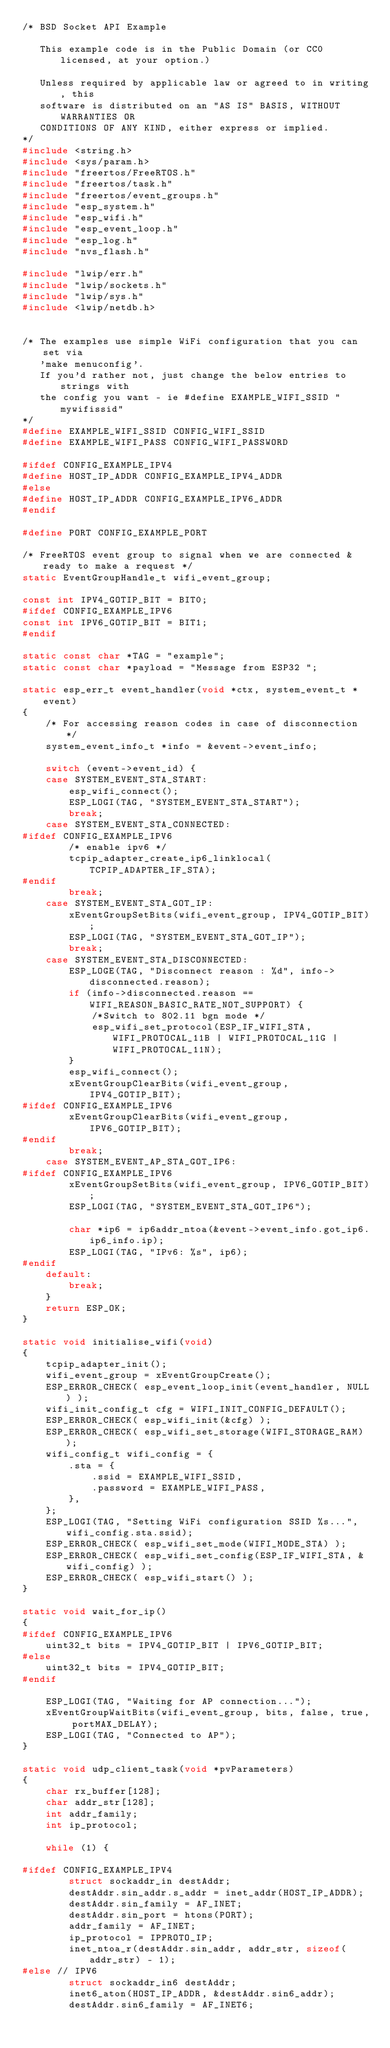Convert code to text. <code><loc_0><loc_0><loc_500><loc_500><_C_>/* BSD Socket API Example

   This example code is in the Public Domain (or CC0 licensed, at your option.)

   Unless required by applicable law or agreed to in writing, this
   software is distributed on an "AS IS" BASIS, WITHOUT WARRANTIES OR
   CONDITIONS OF ANY KIND, either express or implied.
*/
#include <string.h>
#include <sys/param.h>
#include "freertos/FreeRTOS.h"
#include "freertos/task.h"
#include "freertos/event_groups.h"
#include "esp_system.h"
#include "esp_wifi.h"
#include "esp_event_loop.h"
#include "esp_log.h"
#include "nvs_flash.h"

#include "lwip/err.h"
#include "lwip/sockets.h"
#include "lwip/sys.h"
#include <lwip/netdb.h>


/* The examples use simple WiFi configuration that you can set via
   'make menuconfig'.
   If you'd rather not, just change the below entries to strings with
   the config you want - ie #define EXAMPLE_WIFI_SSID "mywifissid"
*/
#define EXAMPLE_WIFI_SSID CONFIG_WIFI_SSID
#define EXAMPLE_WIFI_PASS CONFIG_WIFI_PASSWORD

#ifdef CONFIG_EXAMPLE_IPV4
#define HOST_IP_ADDR CONFIG_EXAMPLE_IPV4_ADDR
#else
#define HOST_IP_ADDR CONFIG_EXAMPLE_IPV6_ADDR
#endif

#define PORT CONFIG_EXAMPLE_PORT

/* FreeRTOS event group to signal when we are connected & ready to make a request */
static EventGroupHandle_t wifi_event_group;

const int IPV4_GOTIP_BIT = BIT0;
#ifdef CONFIG_EXAMPLE_IPV6
const int IPV6_GOTIP_BIT = BIT1;
#endif

static const char *TAG = "example";
static const char *payload = "Message from ESP32 ";

static esp_err_t event_handler(void *ctx, system_event_t *event)
{
    /* For accessing reason codes in case of disconnection */
    system_event_info_t *info = &event->event_info;
    
    switch (event->event_id) {
    case SYSTEM_EVENT_STA_START:
        esp_wifi_connect();
        ESP_LOGI(TAG, "SYSTEM_EVENT_STA_START");
        break;
    case SYSTEM_EVENT_STA_CONNECTED:
#ifdef CONFIG_EXAMPLE_IPV6
        /* enable ipv6 */
        tcpip_adapter_create_ip6_linklocal(TCPIP_ADAPTER_IF_STA);
#endif
        break;
    case SYSTEM_EVENT_STA_GOT_IP:
        xEventGroupSetBits(wifi_event_group, IPV4_GOTIP_BIT);
        ESP_LOGI(TAG, "SYSTEM_EVENT_STA_GOT_IP");
        break;
    case SYSTEM_EVENT_STA_DISCONNECTED:
        ESP_LOGE(TAG, "Disconnect reason : %d", info->disconnected.reason);
        if (info->disconnected.reason == WIFI_REASON_BASIC_RATE_NOT_SUPPORT) {
            /*Switch to 802.11 bgn mode */
            esp_wifi_set_protocol(ESP_IF_WIFI_STA, WIFI_PROTOCAL_11B | WIFI_PROTOCAL_11G | WIFI_PROTOCAL_11N);
        }
        esp_wifi_connect();
        xEventGroupClearBits(wifi_event_group, IPV4_GOTIP_BIT);
#ifdef CONFIG_EXAMPLE_IPV6
        xEventGroupClearBits(wifi_event_group, IPV6_GOTIP_BIT);
#endif
        break;
    case SYSTEM_EVENT_AP_STA_GOT_IP6:
#ifdef CONFIG_EXAMPLE_IPV6
        xEventGroupSetBits(wifi_event_group, IPV6_GOTIP_BIT);
        ESP_LOGI(TAG, "SYSTEM_EVENT_STA_GOT_IP6");

        char *ip6 = ip6addr_ntoa(&event->event_info.got_ip6.ip6_info.ip);
        ESP_LOGI(TAG, "IPv6: %s", ip6);
#endif
    default:
        break;
    }
    return ESP_OK;
}

static void initialise_wifi(void)
{
    tcpip_adapter_init();
    wifi_event_group = xEventGroupCreate();
    ESP_ERROR_CHECK( esp_event_loop_init(event_handler, NULL) );
    wifi_init_config_t cfg = WIFI_INIT_CONFIG_DEFAULT();
    ESP_ERROR_CHECK( esp_wifi_init(&cfg) );
    ESP_ERROR_CHECK( esp_wifi_set_storage(WIFI_STORAGE_RAM) );
    wifi_config_t wifi_config = {
        .sta = {
            .ssid = EXAMPLE_WIFI_SSID,
            .password = EXAMPLE_WIFI_PASS,
        },
    };
    ESP_LOGI(TAG, "Setting WiFi configuration SSID %s...", wifi_config.sta.ssid);
    ESP_ERROR_CHECK( esp_wifi_set_mode(WIFI_MODE_STA) );
    ESP_ERROR_CHECK( esp_wifi_set_config(ESP_IF_WIFI_STA, &wifi_config) );
    ESP_ERROR_CHECK( esp_wifi_start() );
}

static void wait_for_ip()
{
#ifdef CONFIG_EXAMPLE_IPV6
    uint32_t bits = IPV4_GOTIP_BIT | IPV6_GOTIP_BIT;
#else
    uint32_t bits = IPV4_GOTIP_BIT;
#endif

    ESP_LOGI(TAG, "Waiting for AP connection...");
    xEventGroupWaitBits(wifi_event_group, bits, false, true, portMAX_DELAY);
    ESP_LOGI(TAG, "Connected to AP");
}

static void udp_client_task(void *pvParameters)
{
    char rx_buffer[128];
    char addr_str[128];
    int addr_family;
    int ip_protocol;

    while (1) {

#ifdef CONFIG_EXAMPLE_IPV4
        struct sockaddr_in destAddr;
        destAddr.sin_addr.s_addr = inet_addr(HOST_IP_ADDR);
        destAddr.sin_family = AF_INET;
        destAddr.sin_port = htons(PORT);
        addr_family = AF_INET;
        ip_protocol = IPPROTO_IP;
        inet_ntoa_r(destAddr.sin_addr, addr_str, sizeof(addr_str) - 1);
#else // IPV6
        struct sockaddr_in6 destAddr;
        inet6_aton(HOST_IP_ADDR, &destAddr.sin6_addr);
        destAddr.sin6_family = AF_INET6;</code> 